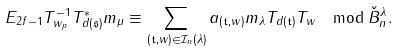<formula> <loc_0><loc_0><loc_500><loc_500>E _ { 2 f - 1 } T _ { w _ { p } } ^ { - 1 } T _ { d ( \mathfrak { s } ) } ^ { * } m _ { \mu } \equiv \sum _ { ( \mathfrak { t } , w ) \in \mathcal { I } _ { n } ( \lambda ) } a _ { ( \mathfrak { t } , w ) } m _ { \lambda } T _ { d ( \mathfrak { t } ) } T _ { w } \mod { \check { B } _ { n } ^ { \lambda } } .</formula> 